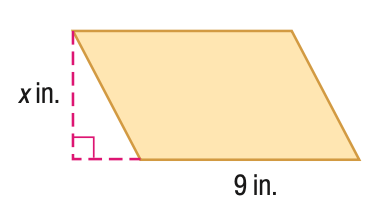Answer the mathemtical geometry problem and directly provide the correct option letter.
Question: Find x. A = 153 in^2.
Choices: A: 15 B: 17 C: 19 D: 21 B 